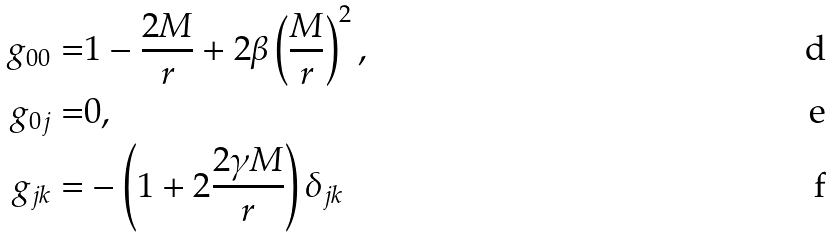Convert formula to latex. <formula><loc_0><loc_0><loc_500><loc_500>g _ { 0 0 } = & 1 - \frac { 2 M } { r } + 2 \beta \left ( \frac { M } { r } \right ) ^ { 2 } , \\ g _ { 0 j } = & 0 , \\ g _ { j k } = & - \left ( 1 + 2 \frac { 2 \gamma M } { r } \right ) \delta _ { j k }</formula> 